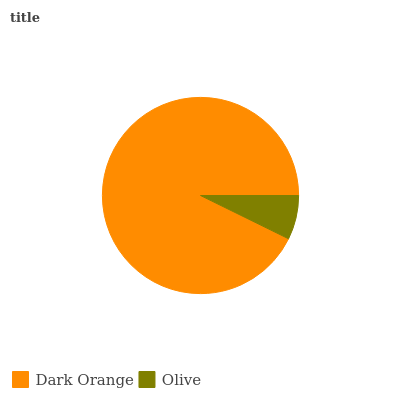Is Olive the minimum?
Answer yes or no. Yes. Is Dark Orange the maximum?
Answer yes or no. Yes. Is Olive the maximum?
Answer yes or no. No. Is Dark Orange greater than Olive?
Answer yes or no. Yes. Is Olive less than Dark Orange?
Answer yes or no. Yes. Is Olive greater than Dark Orange?
Answer yes or no. No. Is Dark Orange less than Olive?
Answer yes or no. No. Is Dark Orange the high median?
Answer yes or no. Yes. Is Olive the low median?
Answer yes or no. Yes. Is Olive the high median?
Answer yes or no. No. Is Dark Orange the low median?
Answer yes or no. No. 